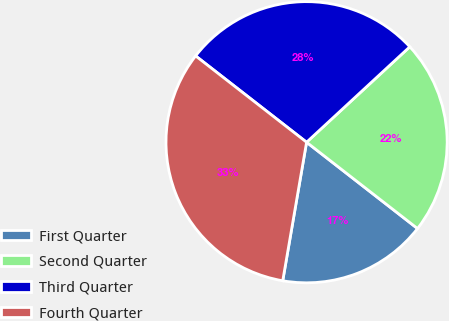<chart> <loc_0><loc_0><loc_500><loc_500><pie_chart><fcel>First Quarter<fcel>Second Quarter<fcel>Third Quarter<fcel>Fourth Quarter<nl><fcel>17.19%<fcel>22.4%<fcel>27.6%<fcel>32.81%<nl></chart> 